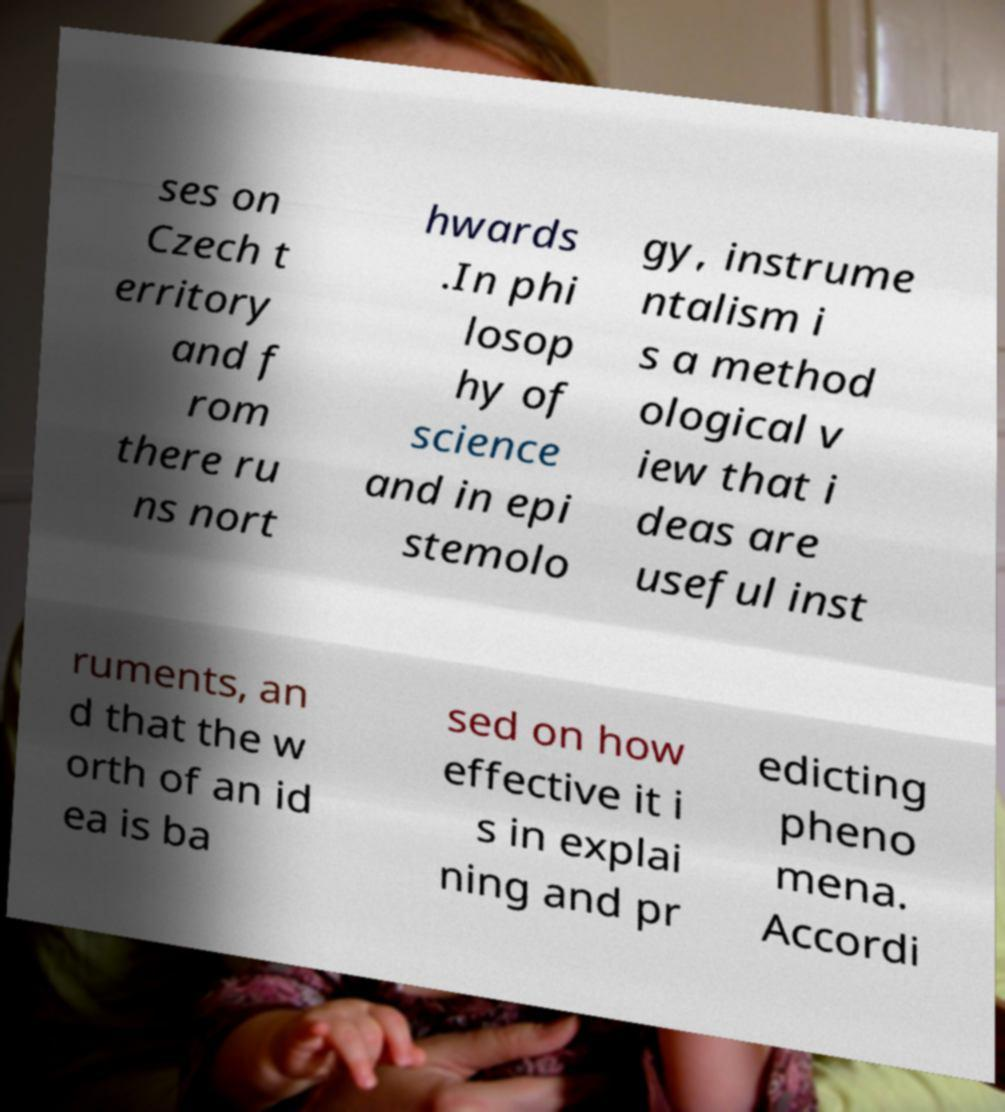Please identify and transcribe the text found in this image. ses on Czech t erritory and f rom there ru ns nort hwards .In phi losop hy of science and in epi stemolo gy, instrume ntalism i s a method ological v iew that i deas are useful inst ruments, an d that the w orth of an id ea is ba sed on how effective it i s in explai ning and pr edicting pheno mena. Accordi 